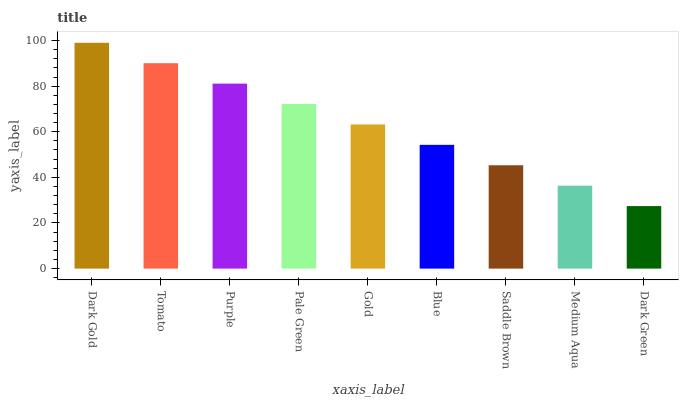Is Tomato the minimum?
Answer yes or no. No. Is Tomato the maximum?
Answer yes or no. No. Is Dark Gold greater than Tomato?
Answer yes or no. Yes. Is Tomato less than Dark Gold?
Answer yes or no. Yes. Is Tomato greater than Dark Gold?
Answer yes or no. No. Is Dark Gold less than Tomato?
Answer yes or no. No. Is Gold the high median?
Answer yes or no. Yes. Is Gold the low median?
Answer yes or no. Yes. Is Purple the high median?
Answer yes or no. No. Is Medium Aqua the low median?
Answer yes or no. No. 